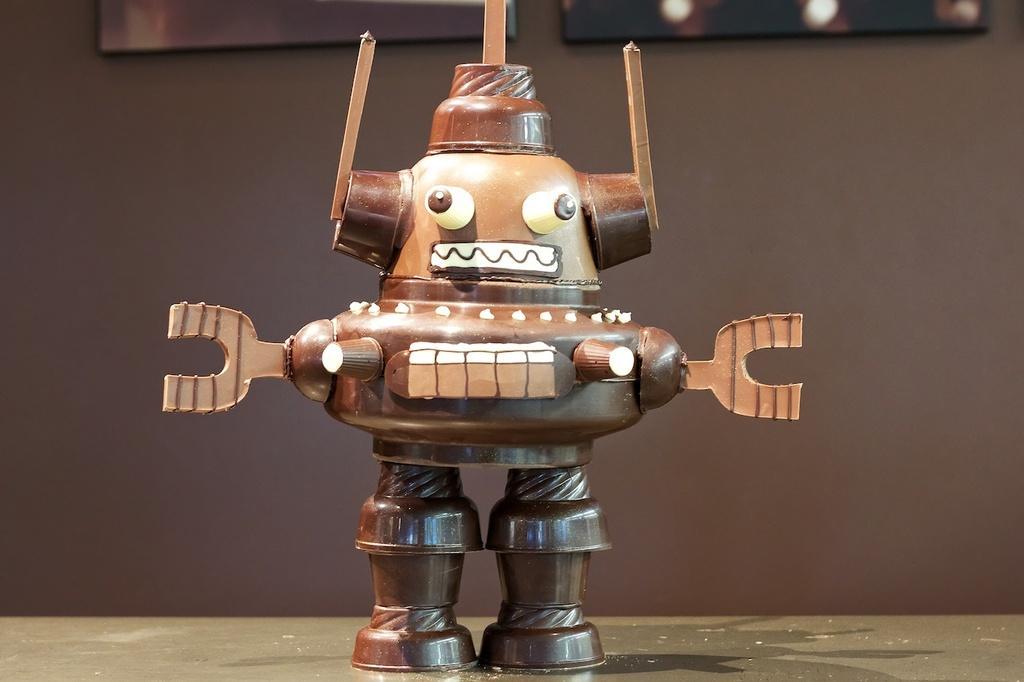In one or two sentences, can you explain what this image depicts? In this image I can see a brown colour thing over here. I can also see this image is little bit blurry from background. 